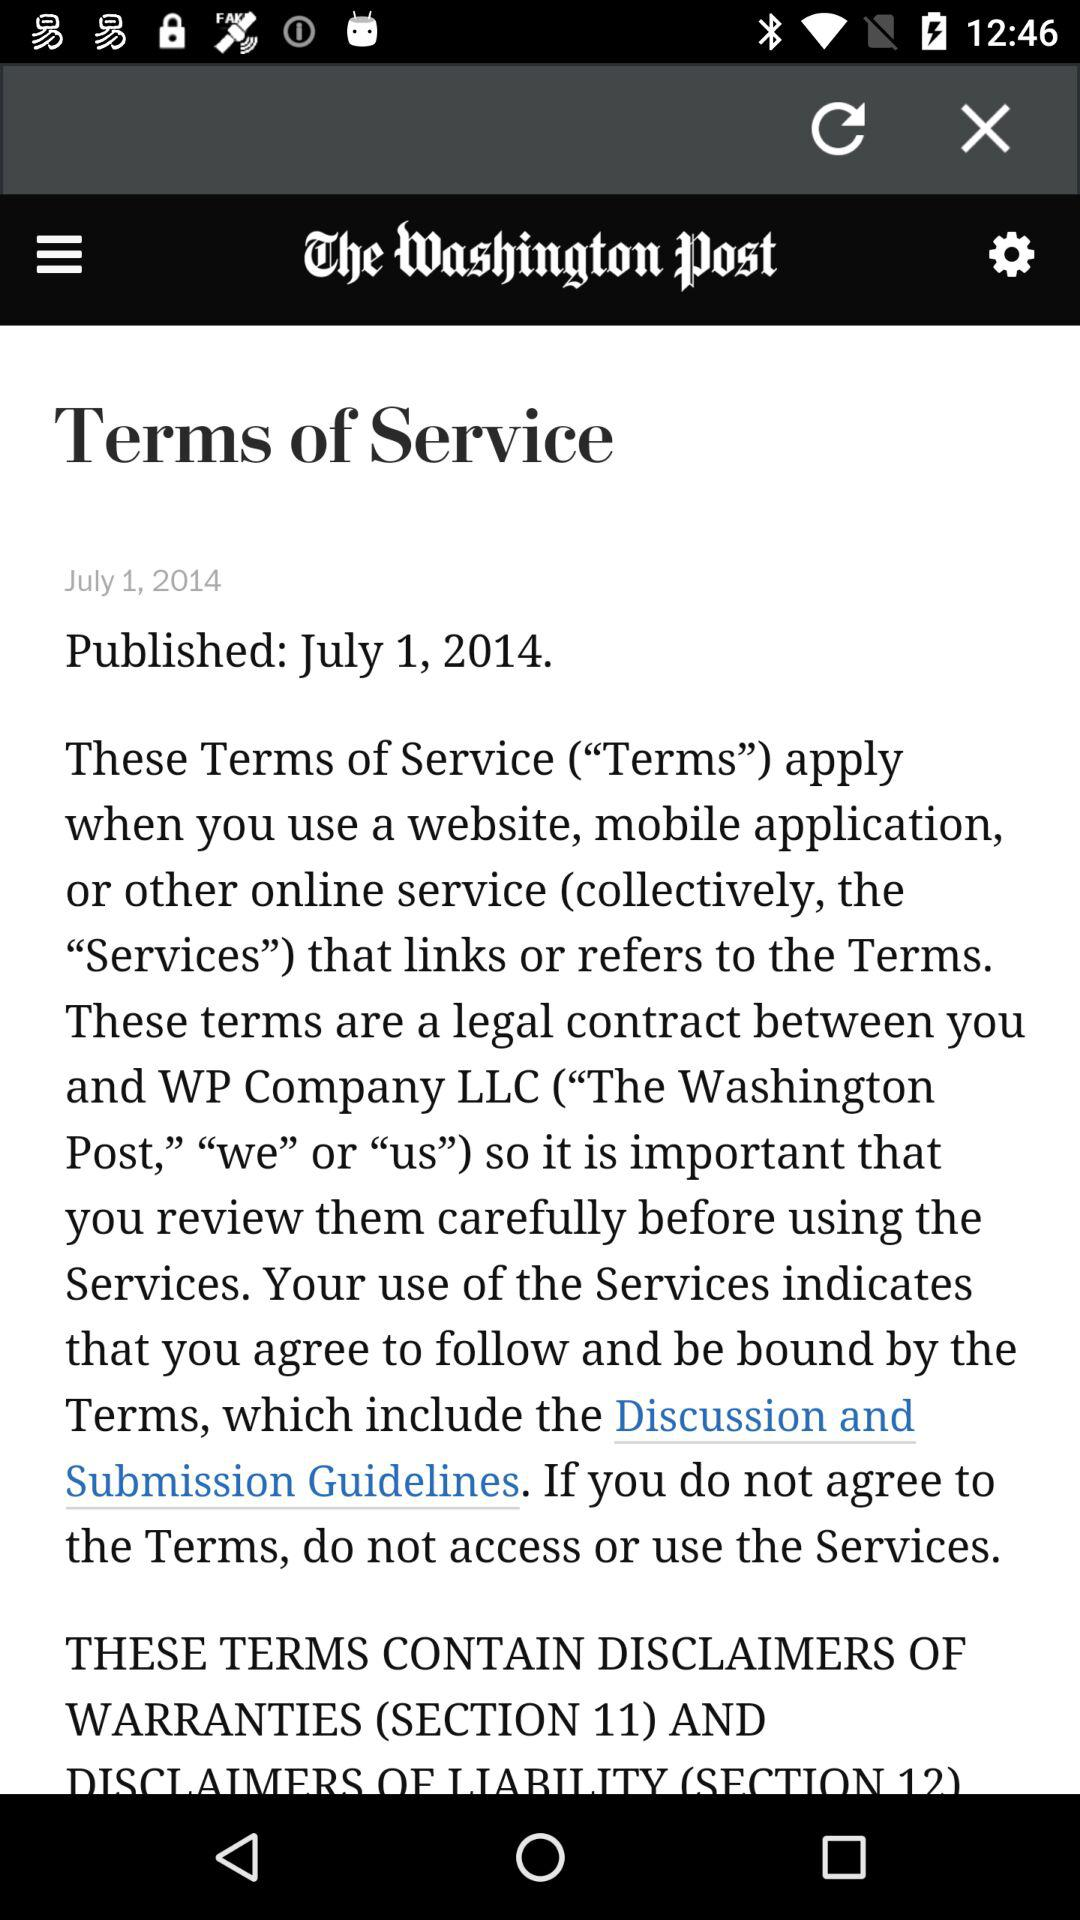What is the application name? The application name is "The Washington Post". 